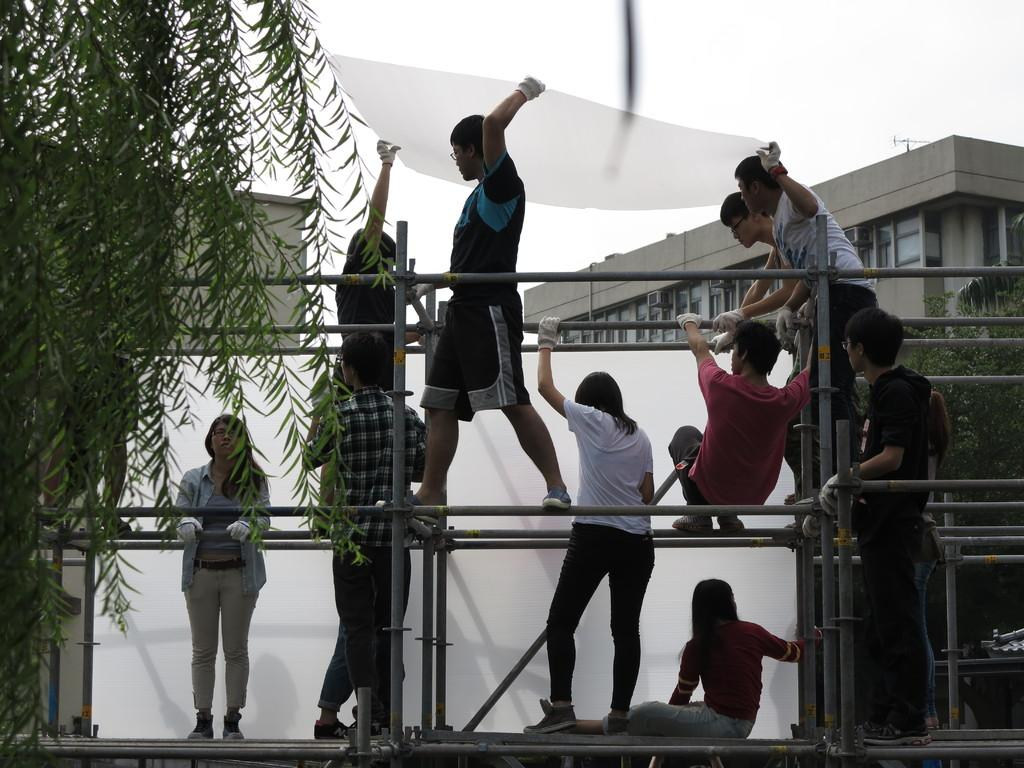How many people are in the image? There is a group of people in the image, but the exact number is not specified. What are the people in the image doing? Some people are standing, while others are sitting. What can be seen in the image besides the people? There are poles in the image. What is visible in the background of the image? There are buildings in the background of the image. What type of memory is being used by the people in the image? There is no indication in the image that the people are using any specific type of memory. Can you tell me how many hearts are visible in the image? There are no hearts visible in the image. 